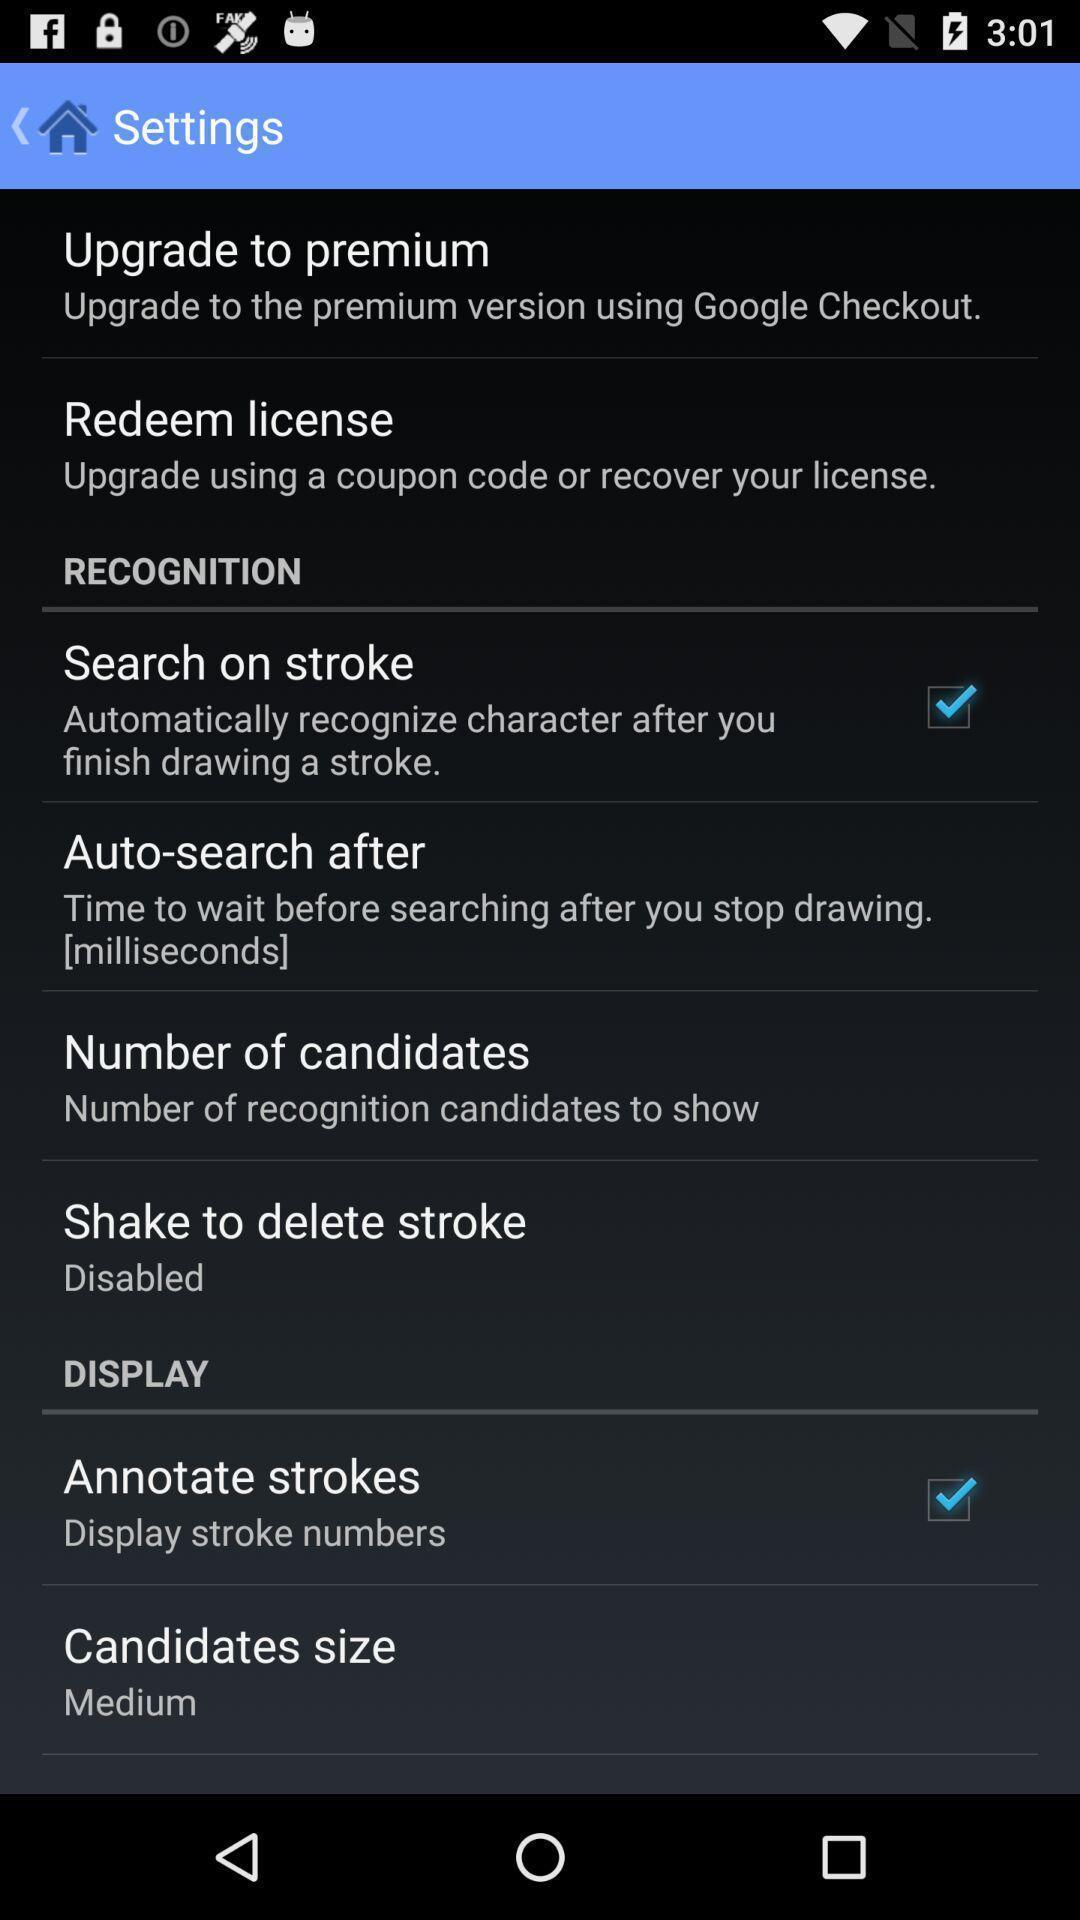Please provide a description for this image. Page with options in settings of a phone. 